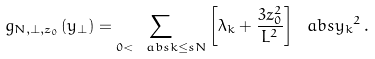Convert formula to latex. <formula><loc_0><loc_0><loc_500><loc_500>g _ { N , \perp , z _ { 0 } } ( y _ { \perp } ) = \sum _ { 0 < \ a b s { k } \leq s N } \left [ \lambda _ { k } + \frac { 3 z _ { 0 } ^ { 2 } } { L ^ { 2 } } \right ] \ a b s { y _ { k } } ^ { 2 } \, .</formula> 